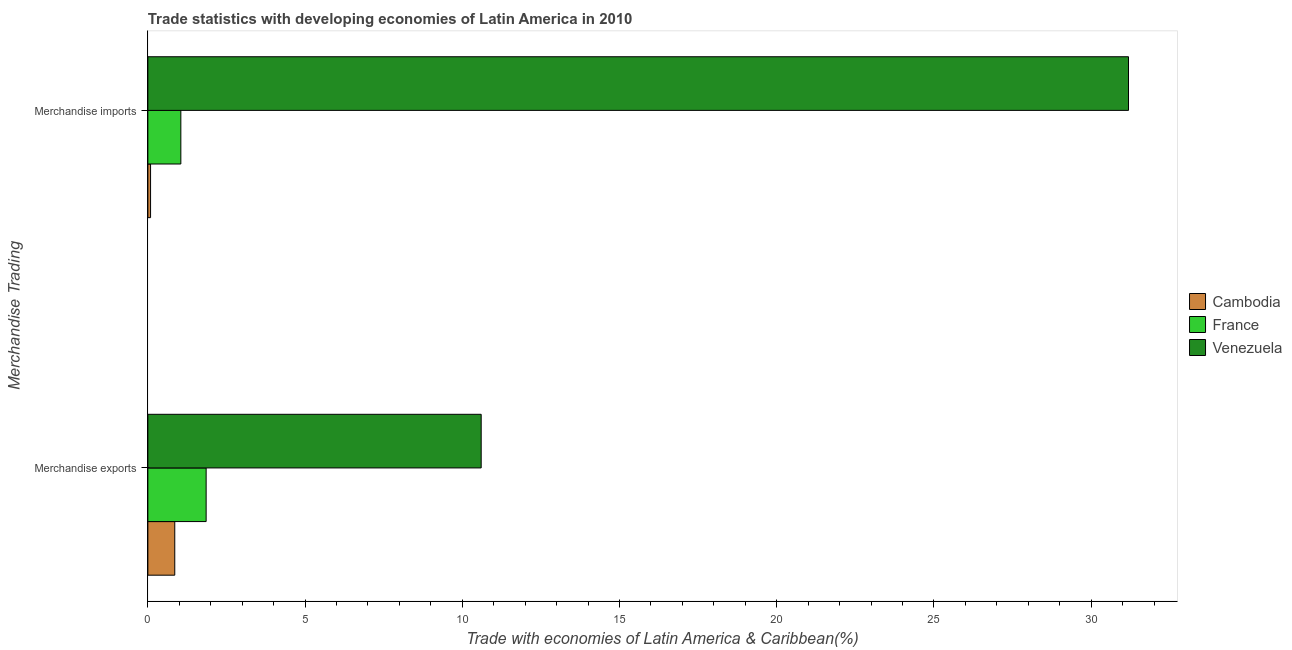Are the number of bars per tick equal to the number of legend labels?
Your response must be concise. Yes. Are the number of bars on each tick of the Y-axis equal?
Offer a terse response. Yes. How many bars are there on the 2nd tick from the top?
Provide a short and direct response. 3. How many bars are there on the 1st tick from the bottom?
Make the answer very short. 3. What is the label of the 2nd group of bars from the top?
Make the answer very short. Merchandise exports. What is the merchandise imports in France?
Your answer should be compact. 1.05. Across all countries, what is the maximum merchandise imports?
Offer a terse response. 31.19. Across all countries, what is the minimum merchandise exports?
Give a very brief answer. 0.86. In which country was the merchandise exports maximum?
Ensure brevity in your answer.  Venezuela. In which country was the merchandise exports minimum?
Your answer should be compact. Cambodia. What is the total merchandise imports in the graph?
Give a very brief answer. 32.32. What is the difference between the merchandise exports in Cambodia and that in France?
Provide a succinct answer. -1. What is the difference between the merchandise exports in France and the merchandise imports in Venezuela?
Keep it short and to the point. -29.33. What is the average merchandise exports per country?
Your response must be concise. 4.44. What is the difference between the merchandise imports and merchandise exports in Cambodia?
Provide a succinct answer. -0.77. In how many countries, is the merchandise imports greater than 24 %?
Keep it short and to the point. 1. What is the ratio of the merchandise exports in Cambodia to that in France?
Your answer should be very brief. 0.46. Is the merchandise exports in Cambodia less than that in Venezuela?
Give a very brief answer. Yes. In how many countries, is the merchandise exports greater than the average merchandise exports taken over all countries?
Ensure brevity in your answer.  1. What does the 3rd bar from the bottom in Merchandise exports represents?
Make the answer very short. Venezuela. Are all the bars in the graph horizontal?
Your response must be concise. Yes. Are the values on the major ticks of X-axis written in scientific E-notation?
Provide a succinct answer. No. Where does the legend appear in the graph?
Your answer should be very brief. Center right. What is the title of the graph?
Make the answer very short. Trade statistics with developing economies of Latin America in 2010. Does "Solomon Islands" appear as one of the legend labels in the graph?
Offer a very short reply. No. What is the label or title of the X-axis?
Your answer should be compact. Trade with economies of Latin America & Caribbean(%). What is the label or title of the Y-axis?
Provide a succinct answer. Merchandise Trading. What is the Trade with economies of Latin America & Caribbean(%) in Cambodia in Merchandise exports?
Give a very brief answer. 0.86. What is the Trade with economies of Latin America & Caribbean(%) in France in Merchandise exports?
Provide a short and direct response. 1.85. What is the Trade with economies of Latin America & Caribbean(%) in Venezuela in Merchandise exports?
Your answer should be very brief. 10.6. What is the Trade with economies of Latin America & Caribbean(%) in Cambodia in Merchandise imports?
Give a very brief answer. 0.09. What is the Trade with economies of Latin America & Caribbean(%) of France in Merchandise imports?
Give a very brief answer. 1.05. What is the Trade with economies of Latin America & Caribbean(%) in Venezuela in Merchandise imports?
Ensure brevity in your answer.  31.19. Across all Merchandise Trading, what is the maximum Trade with economies of Latin America & Caribbean(%) in Cambodia?
Offer a terse response. 0.86. Across all Merchandise Trading, what is the maximum Trade with economies of Latin America & Caribbean(%) of France?
Your answer should be very brief. 1.85. Across all Merchandise Trading, what is the maximum Trade with economies of Latin America & Caribbean(%) in Venezuela?
Give a very brief answer. 31.19. Across all Merchandise Trading, what is the minimum Trade with economies of Latin America & Caribbean(%) in Cambodia?
Offer a very short reply. 0.09. Across all Merchandise Trading, what is the minimum Trade with economies of Latin America & Caribbean(%) in France?
Offer a very short reply. 1.05. Across all Merchandise Trading, what is the minimum Trade with economies of Latin America & Caribbean(%) in Venezuela?
Make the answer very short. 10.6. What is the total Trade with economies of Latin America & Caribbean(%) in Cambodia in the graph?
Give a very brief answer. 0.94. What is the total Trade with economies of Latin America & Caribbean(%) of France in the graph?
Offer a terse response. 2.9. What is the total Trade with economies of Latin America & Caribbean(%) of Venezuela in the graph?
Offer a terse response. 41.79. What is the difference between the Trade with economies of Latin America & Caribbean(%) in Cambodia in Merchandise exports and that in Merchandise imports?
Keep it short and to the point. 0.77. What is the difference between the Trade with economies of Latin America & Caribbean(%) of France in Merchandise exports and that in Merchandise imports?
Your answer should be very brief. 0.8. What is the difference between the Trade with economies of Latin America & Caribbean(%) in Venezuela in Merchandise exports and that in Merchandise imports?
Offer a terse response. -20.59. What is the difference between the Trade with economies of Latin America & Caribbean(%) of Cambodia in Merchandise exports and the Trade with economies of Latin America & Caribbean(%) of France in Merchandise imports?
Provide a succinct answer. -0.19. What is the difference between the Trade with economies of Latin America & Caribbean(%) in Cambodia in Merchandise exports and the Trade with economies of Latin America & Caribbean(%) in Venezuela in Merchandise imports?
Keep it short and to the point. -30.33. What is the difference between the Trade with economies of Latin America & Caribbean(%) in France in Merchandise exports and the Trade with economies of Latin America & Caribbean(%) in Venezuela in Merchandise imports?
Give a very brief answer. -29.33. What is the average Trade with economies of Latin America & Caribbean(%) of Cambodia per Merchandise Trading?
Make the answer very short. 0.47. What is the average Trade with economies of Latin America & Caribbean(%) in France per Merchandise Trading?
Keep it short and to the point. 1.45. What is the average Trade with economies of Latin America & Caribbean(%) in Venezuela per Merchandise Trading?
Your response must be concise. 20.89. What is the difference between the Trade with economies of Latin America & Caribbean(%) of Cambodia and Trade with economies of Latin America & Caribbean(%) of France in Merchandise exports?
Make the answer very short. -1. What is the difference between the Trade with economies of Latin America & Caribbean(%) of Cambodia and Trade with economies of Latin America & Caribbean(%) of Venezuela in Merchandise exports?
Your answer should be very brief. -9.74. What is the difference between the Trade with economies of Latin America & Caribbean(%) of France and Trade with economies of Latin America & Caribbean(%) of Venezuela in Merchandise exports?
Make the answer very short. -8.75. What is the difference between the Trade with economies of Latin America & Caribbean(%) in Cambodia and Trade with economies of Latin America & Caribbean(%) in France in Merchandise imports?
Offer a terse response. -0.96. What is the difference between the Trade with economies of Latin America & Caribbean(%) in Cambodia and Trade with economies of Latin America & Caribbean(%) in Venezuela in Merchandise imports?
Make the answer very short. -31.1. What is the difference between the Trade with economies of Latin America & Caribbean(%) in France and Trade with economies of Latin America & Caribbean(%) in Venezuela in Merchandise imports?
Provide a short and direct response. -30.14. What is the ratio of the Trade with economies of Latin America & Caribbean(%) in Cambodia in Merchandise exports to that in Merchandise imports?
Provide a short and direct response. 9.97. What is the ratio of the Trade with economies of Latin America & Caribbean(%) of France in Merchandise exports to that in Merchandise imports?
Ensure brevity in your answer.  1.77. What is the ratio of the Trade with economies of Latin America & Caribbean(%) in Venezuela in Merchandise exports to that in Merchandise imports?
Make the answer very short. 0.34. What is the difference between the highest and the second highest Trade with economies of Latin America & Caribbean(%) of Cambodia?
Your answer should be very brief. 0.77. What is the difference between the highest and the second highest Trade with economies of Latin America & Caribbean(%) in France?
Ensure brevity in your answer.  0.8. What is the difference between the highest and the second highest Trade with economies of Latin America & Caribbean(%) of Venezuela?
Offer a terse response. 20.59. What is the difference between the highest and the lowest Trade with economies of Latin America & Caribbean(%) in Cambodia?
Offer a very short reply. 0.77. What is the difference between the highest and the lowest Trade with economies of Latin America & Caribbean(%) of France?
Make the answer very short. 0.8. What is the difference between the highest and the lowest Trade with economies of Latin America & Caribbean(%) of Venezuela?
Your answer should be very brief. 20.59. 